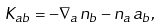<formula> <loc_0><loc_0><loc_500><loc_500>K _ { a b } = - \nabla _ { a } n _ { b } - n _ { a } a _ { b } ,</formula> 